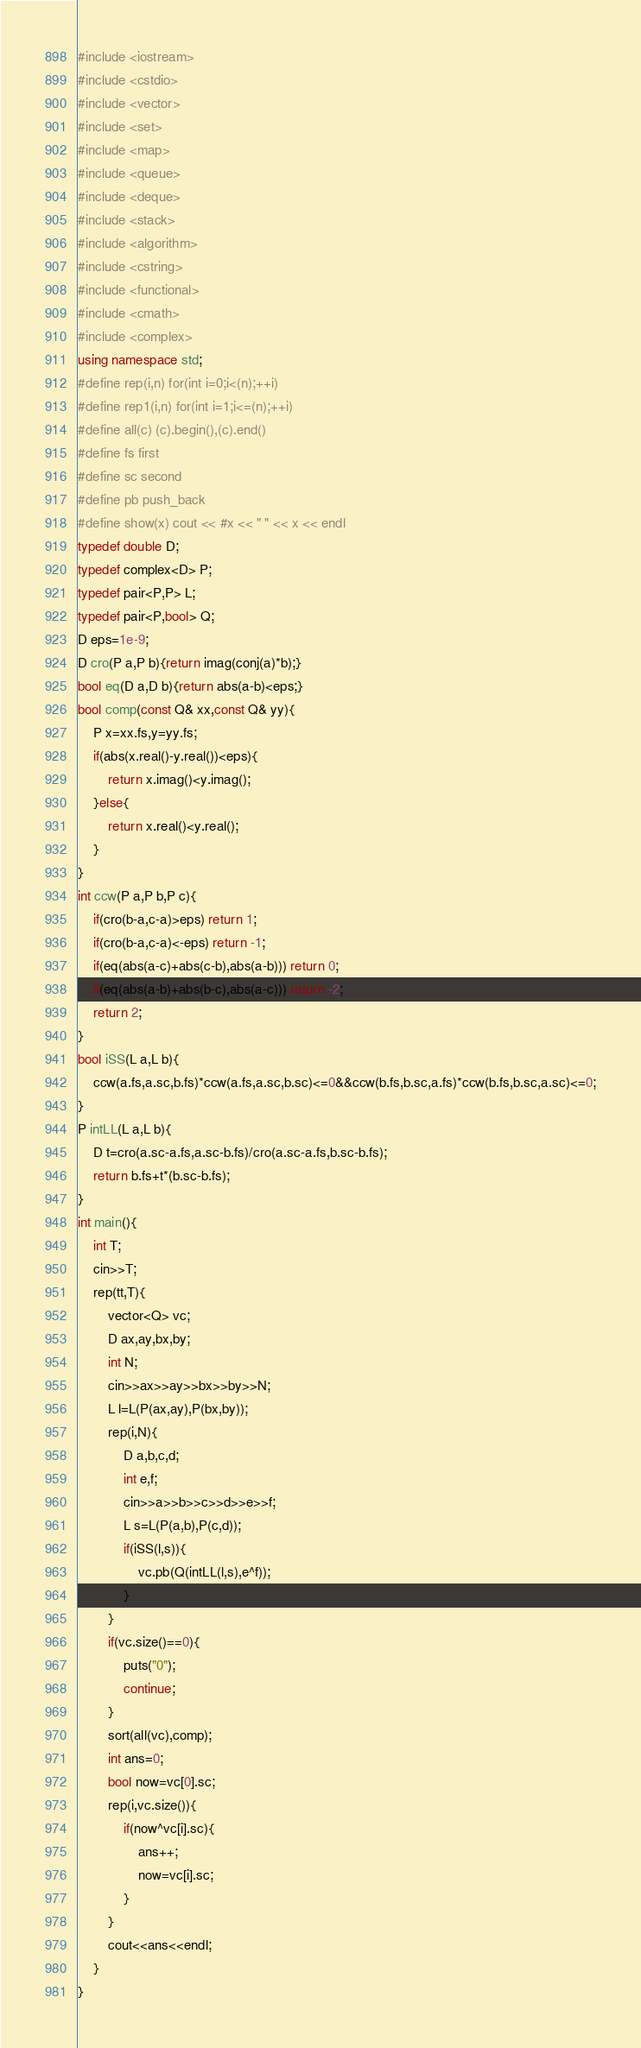Convert code to text. <code><loc_0><loc_0><loc_500><loc_500><_C++_>#include <iostream>
#include <cstdio>
#include <vector>
#include <set>
#include <map>
#include <queue>
#include <deque>
#include <stack>
#include <algorithm>
#include <cstring>
#include <functional>
#include <cmath>
#include <complex>
using namespace std;
#define rep(i,n) for(int i=0;i<(n);++i)
#define rep1(i,n) for(int i=1;i<=(n);++i)
#define all(c) (c).begin(),(c).end()
#define fs first
#define sc second
#define pb push_back
#define show(x) cout << #x << " " << x << endl
typedef double D;
typedef complex<D> P;
typedef pair<P,P> L;
typedef pair<P,bool> Q;
D eps=1e-9;
D cro(P a,P b){return imag(conj(a)*b);}
bool eq(D a,D b){return abs(a-b)<eps;}
bool comp(const Q& xx,const Q& yy){
	P x=xx.fs,y=yy.fs;
	if(abs(x.real()-y.real())<eps){
		return x.imag()<y.imag();
	}else{
		return x.real()<y.real();
	}
}
int ccw(P a,P b,P c){
	if(cro(b-a,c-a)>eps) return 1;
	if(cro(b-a,c-a)<-eps) return -1;
	if(eq(abs(a-c)+abs(c-b),abs(a-b))) return 0;
	if(eq(abs(a-b)+abs(b-c),abs(a-c))) return -2;
	return 2;
}
bool iSS(L a,L b){
	ccw(a.fs,a.sc,b.fs)*ccw(a.fs,a.sc,b.sc)<=0&&ccw(b.fs,b.sc,a.fs)*ccw(b.fs,b.sc,a.sc)<=0;
}
P intLL(L a,L b){
	D t=cro(a.sc-a.fs,a.sc-b.fs)/cro(a.sc-a.fs,b.sc-b.fs);
	return b.fs+t*(b.sc-b.fs);
}
int main(){
	int T;
	cin>>T;
	rep(tt,T){
		vector<Q> vc;
		D ax,ay,bx,by;
		int N;
		cin>>ax>>ay>>bx>>by>>N;
		L l=L(P(ax,ay),P(bx,by));
		rep(i,N){
			D a,b,c,d;
			int e,f;
			cin>>a>>b>>c>>d>>e>>f;
			L s=L(P(a,b),P(c,d));
			if(iSS(l,s)){
				vc.pb(Q(intLL(l,s),e^f));
			}
		}
		if(vc.size()==0){
			puts("0");
			continue;
		}
		sort(all(vc),comp);
		int ans=0;
		bool now=vc[0].sc;
		rep(i,vc.size()){
			if(now^vc[i].sc){
				ans++;
				now=vc[i].sc;
			}
		}
		cout<<ans<<endl;
	}
}</code> 